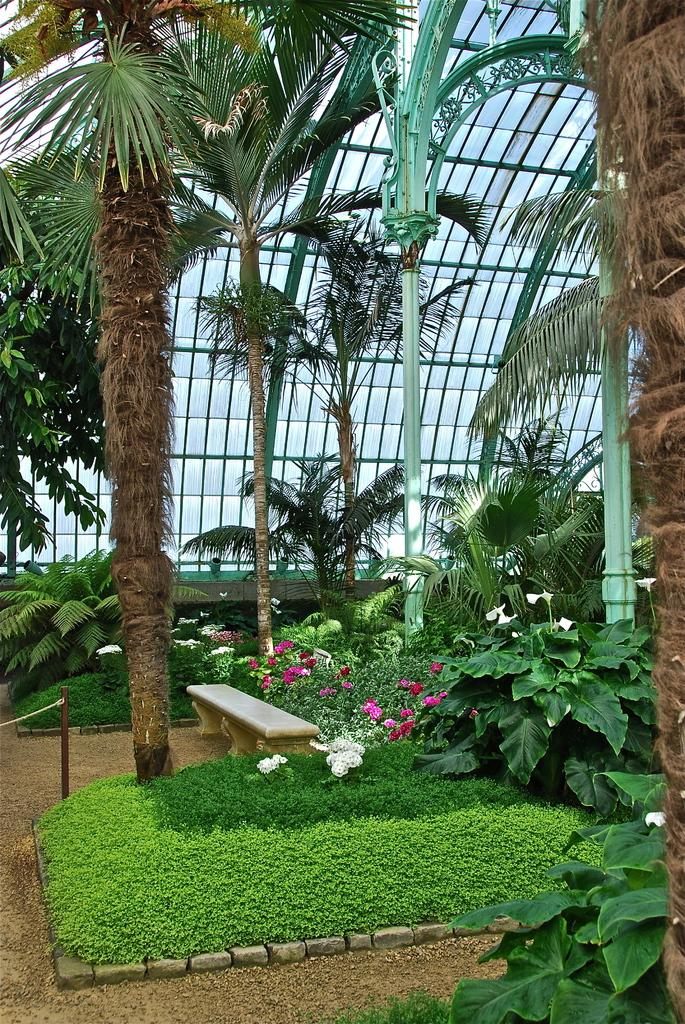What type of vegetation can be seen in the image? There are trees and plants with flowers in the image. Where are the plants with flowers located? The plants with flowers are on the ground under a glass roof. What else can be seen in the image besides vegetation? There are poles visible in the image. Can you describe the argument between the frogs in the image? There are no frogs present in the image, so there cannot be an argument between them. 